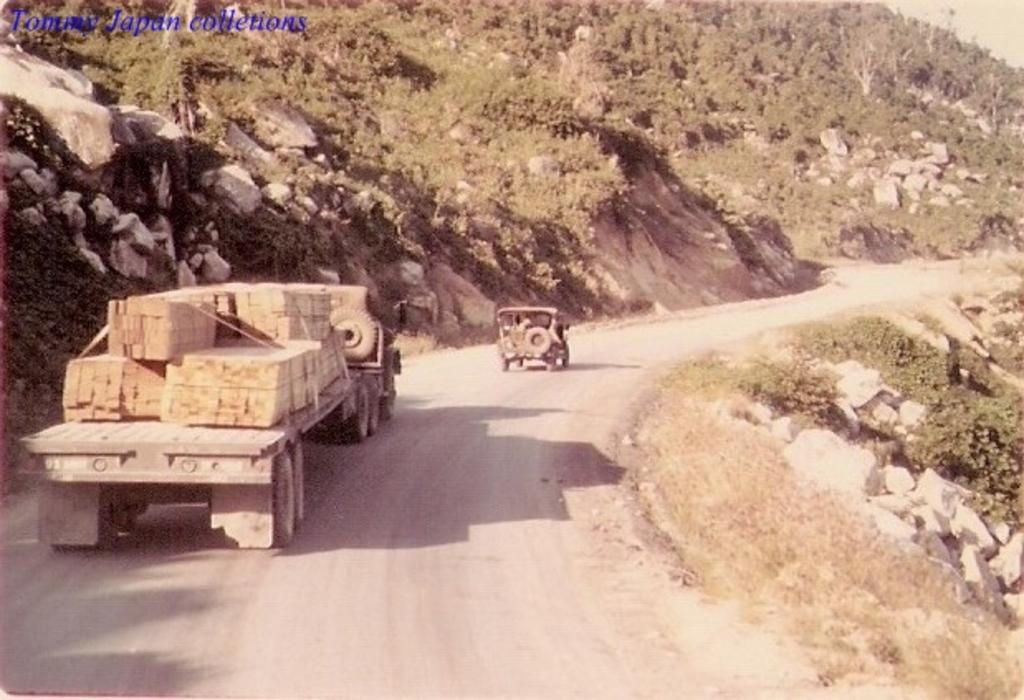What is the main feature of the image? There is a road in the image. What is happening on the road? There are vehicles on the road. What are the vehicles carrying? The vehicles have goods on them. What can be seen on the sides of the road? There are rocks and plants on the sides of the road. Can you describe the watermark in the image? There is a watermark in the top left corner of the image. Can you tell me how many boats are visible in the image? There are no boats present in the image; it features a road with vehicles and surrounding environment. What type of sneeze can be heard coming from the person in the image? There is no person present in the image, nor is there any indication of a sneeze or any sound. 